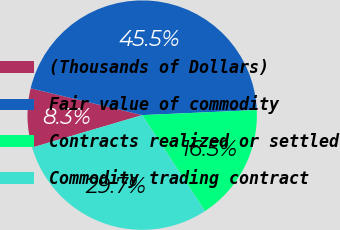Convert chart to OTSL. <chart><loc_0><loc_0><loc_500><loc_500><pie_chart><fcel>(Thousands of Dollars)<fcel>Fair value of commodity<fcel>Contracts realized or settled<fcel>Commodity trading contract<nl><fcel>8.31%<fcel>45.54%<fcel>16.48%<fcel>29.67%<nl></chart> 